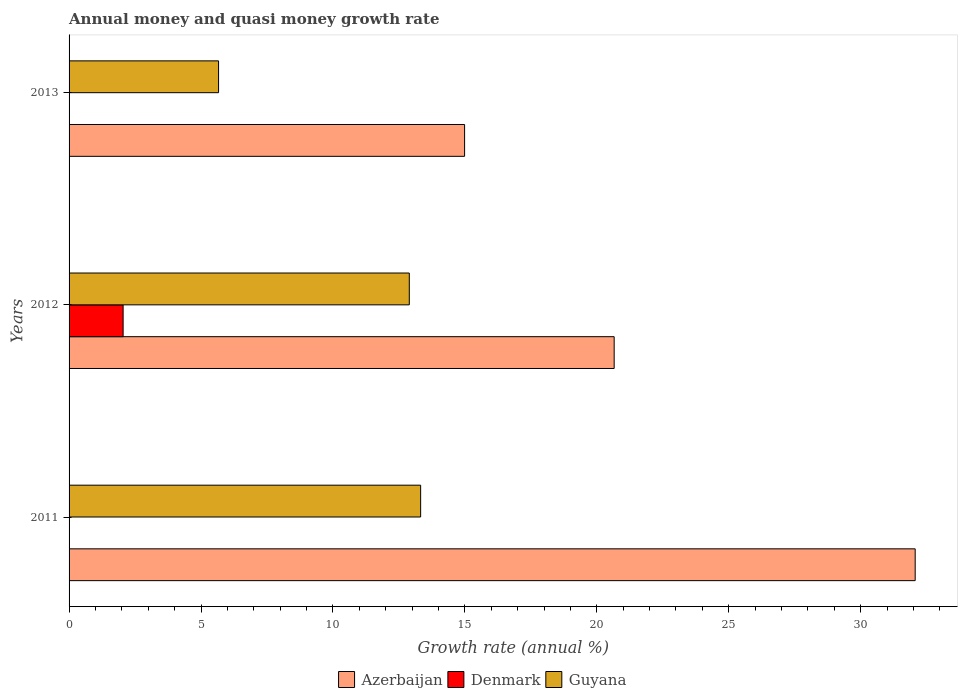How many groups of bars are there?
Your answer should be very brief. 3. Are the number of bars per tick equal to the number of legend labels?
Your response must be concise. No. How many bars are there on the 1st tick from the bottom?
Provide a short and direct response. 2. What is the label of the 2nd group of bars from the top?
Offer a very short reply. 2012. In how many cases, is the number of bars for a given year not equal to the number of legend labels?
Offer a terse response. 2. What is the growth rate in Azerbaijan in 2011?
Keep it short and to the point. 32.07. Across all years, what is the maximum growth rate in Denmark?
Offer a terse response. 2.05. In which year was the growth rate in Guyana maximum?
Make the answer very short. 2011. What is the total growth rate in Guyana in the graph?
Your response must be concise. 31.88. What is the difference between the growth rate in Guyana in 2011 and that in 2012?
Offer a very short reply. 0.43. What is the difference between the growth rate in Azerbaijan in 2011 and the growth rate in Denmark in 2013?
Your response must be concise. 32.07. What is the average growth rate in Guyana per year?
Your answer should be compact. 10.63. In the year 2013, what is the difference between the growth rate in Azerbaijan and growth rate in Guyana?
Provide a short and direct response. 9.32. In how many years, is the growth rate in Azerbaijan greater than 26 %?
Provide a succinct answer. 1. What is the ratio of the growth rate in Guyana in 2011 to that in 2012?
Your answer should be compact. 1.03. Is the difference between the growth rate in Azerbaijan in 2011 and 2013 greater than the difference between the growth rate in Guyana in 2011 and 2013?
Make the answer very short. Yes. What is the difference between the highest and the second highest growth rate in Azerbaijan?
Provide a succinct answer. 11.41. What is the difference between the highest and the lowest growth rate in Denmark?
Offer a terse response. 2.05. Is the sum of the growth rate in Azerbaijan in 2011 and 2013 greater than the maximum growth rate in Denmark across all years?
Ensure brevity in your answer.  Yes. How many bars are there?
Your answer should be very brief. 7. Are all the bars in the graph horizontal?
Your response must be concise. Yes. How many years are there in the graph?
Your answer should be compact. 3. Are the values on the major ticks of X-axis written in scientific E-notation?
Your answer should be compact. No. Does the graph contain any zero values?
Give a very brief answer. Yes. What is the title of the graph?
Provide a short and direct response. Annual money and quasi money growth rate. Does "Monaco" appear as one of the legend labels in the graph?
Offer a very short reply. No. What is the label or title of the X-axis?
Keep it short and to the point. Growth rate (annual %). What is the label or title of the Y-axis?
Provide a short and direct response. Years. What is the Growth rate (annual %) in Azerbaijan in 2011?
Ensure brevity in your answer.  32.07. What is the Growth rate (annual %) in Denmark in 2011?
Make the answer very short. 0. What is the Growth rate (annual %) of Guyana in 2011?
Provide a succinct answer. 13.32. What is the Growth rate (annual %) of Azerbaijan in 2012?
Give a very brief answer. 20.66. What is the Growth rate (annual %) in Denmark in 2012?
Provide a succinct answer. 2.05. What is the Growth rate (annual %) in Guyana in 2012?
Offer a terse response. 12.89. What is the Growth rate (annual %) in Azerbaijan in 2013?
Make the answer very short. 14.99. What is the Growth rate (annual %) of Denmark in 2013?
Offer a very short reply. 0. What is the Growth rate (annual %) in Guyana in 2013?
Ensure brevity in your answer.  5.67. Across all years, what is the maximum Growth rate (annual %) of Azerbaijan?
Your answer should be compact. 32.07. Across all years, what is the maximum Growth rate (annual %) of Denmark?
Offer a very short reply. 2.05. Across all years, what is the maximum Growth rate (annual %) of Guyana?
Your answer should be compact. 13.32. Across all years, what is the minimum Growth rate (annual %) of Azerbaijan?
Your response must be concise. 14.99. Across all years, what is the minimum Growth rate (annual %) of Guyana?
Provide a short and direct response. 5.67. What is the total Growth rate (annual %) of Azerbaijan in the graph?
Ensure brevity in your answer.  67.71. What is the total Growth rate (annual %) in Denmark in the graph?
Your answer should be compact. 2.05. What is the total Growth rate (annual %) in Guyana in the graph?
Provide a short and direct response. 31.88. What is the difference between the Growth rate (annual %) in Azerbaijan in 2011 and that in 2012?
Give a very brief answer. 11.41. What is the difference between the Growth rate (annual %) in Guyana in 2011 and that in 2012?
Keep it short and to the point. 0.43. What is the difference between the Growth rate (annual %) of Azerbaijan in 2011 and that in 2013?
Your answer should be compact. 17.08. What is the difference between the Growth rate (annual %) in Guyana in 2011 and that in 2013?
Ensure brevity in your answer.  7.66. What is the difference between the Growth rate (annual %) of Azerbaijan in 2012 and that in 2013?
Make the answer very short. 5.67. What is the difference between the Growth rate (annual %) in Guyana in 2012 and that in 2013?
Your answer should be very brief. 7.23. What is the difference between the Growth rate (annual %) in Azerbaijan in 2011 and the Growth rate (annual %) in Denmark in 2012?
Provide a short and direct response. 30.02. What is the difference between the Growth rate (annual %) of Azerbaijan in 2011 and the Growth rate (annual %) of Guyana in 2012?
Give a very brief answer. 19.17. What is the difference between the Growth rate (annual %) of Azerbaijan in 2011 and the Growth rate (annual %) of Guyana in 2013?
Ensure brevity in your answer.  26.4. What is the difference between the Growth rate (annual %) in Azerbaijan in 2012 and the Growth rate (annual %) in Guyana in 2013?
Keep it short and to the point. 14.99. What is the difference between the Growth rate (annual %) in Denmark in 2012 and the Growth rate (annual %) in Guyana in 2013?
Your answer should be compact. -3.62. What is the average Growth rate (annual %) of Azerbaijan per year?
Keep it short and to the point. 22.57. What is the average Growth rate (annual %) of Denmark per year?
Keep it short and to the point. 0.68. What is the average Growth rate (annual %) in Guyana per year?
Provide a succinct answer. 10.63. In the year 2011, what is the difference between the Growth rate (annual %) of Azerbaijan and Growth rate (annual %) of Guyana?
Provide a succinct answer. 18.74. In the year 2012, what is the difference between the Growth rate (annual %) in Azerbaijan and Growth rate (annual %) in Denmark?
Your answer should be very brief. 18.61. In the year 2012, what is the difference between the Growth rate (annual %) of Azerbaijan and Growth rate (annual %) of Guyana?
Keep it short and to the point. 7.76. In the year 2012, what is the difference between the Growth rate (annual %) in Denmark and Growth rate (annual %) in Guyana?
Keep it short and to the point. -10.85. In the year 2013, what is the difference between the Growth rate (annual %) of Azerbaijan and Growth rate (annual %) of Guyana?
Make the answer very short. 9.32. What is the ratio of the Growth rate (annual %) in Azerbaijan in 2011 to that in 2012?
Provide a short and direct response. 1.55. What is the ratio of the Growth rate (annual %) of Guyana in 2011 to that in 2012?
Your answer should be compact. 1.03. What is the ratio of the Growth rate (annual %) of Azerbaijan in 2011 to that in 2013?
Provide a short and direct response. 2.14. What is the ratio of the Growth rate (annual %) of Guyana in 2011 to that in 2013?
Keep it short and to the point. 2.35. What is the ratio of the Growth rate (annual %) of Azerbaijan in 2012 to that in 2013?
Provide a short and direct response. 1.38. What is the ratio of the Growth rate (annual %) in Guyana in 2012 to that in 2013?
Offer a very short reply. 2.28. What is the difference between the highest and the second highest Growth rate (annual %) in Azerbaijan?
Make the answer very short. 11.41. What is the difference between the highest and the second highest Growth rate (annual %) of Guyana?
Give a very brief answer. 0.43. What is the difference between the highest and the lowest Growth rate (annual %) in Azerbaijan?
Ensure brevity in your answer.  17.08. What is the difference between the highest and the lowest Growth rate (annual %) in Denmark?
Give a very brief answer. 2.05. What is the difference between the highest and the lowest Growth rate (annual %) of Guyana?
Your response must be concise. 7.66. 